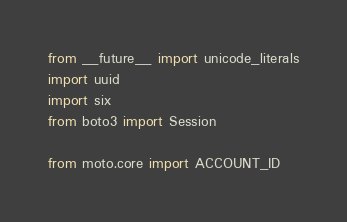Convert code to text. <code><loc_0><loc_0><loc_500><loc_500><_Python_>from __future__ import unicode_literals
import uuid
import six
from boto3 import Session

from moto.core import ACCOUNT_ID</code> 